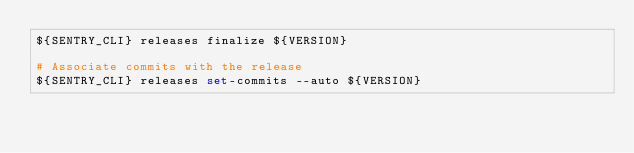Convert code to text. <code><loc_0><loc_0><loc_500><loc_500><_Bash_>${SENTRY_CLI} releases finalize ${VERSION}

# Associate commits with the release
${SENTRY_CLI} releases set-commits --auto ${VERSION}
</code> 